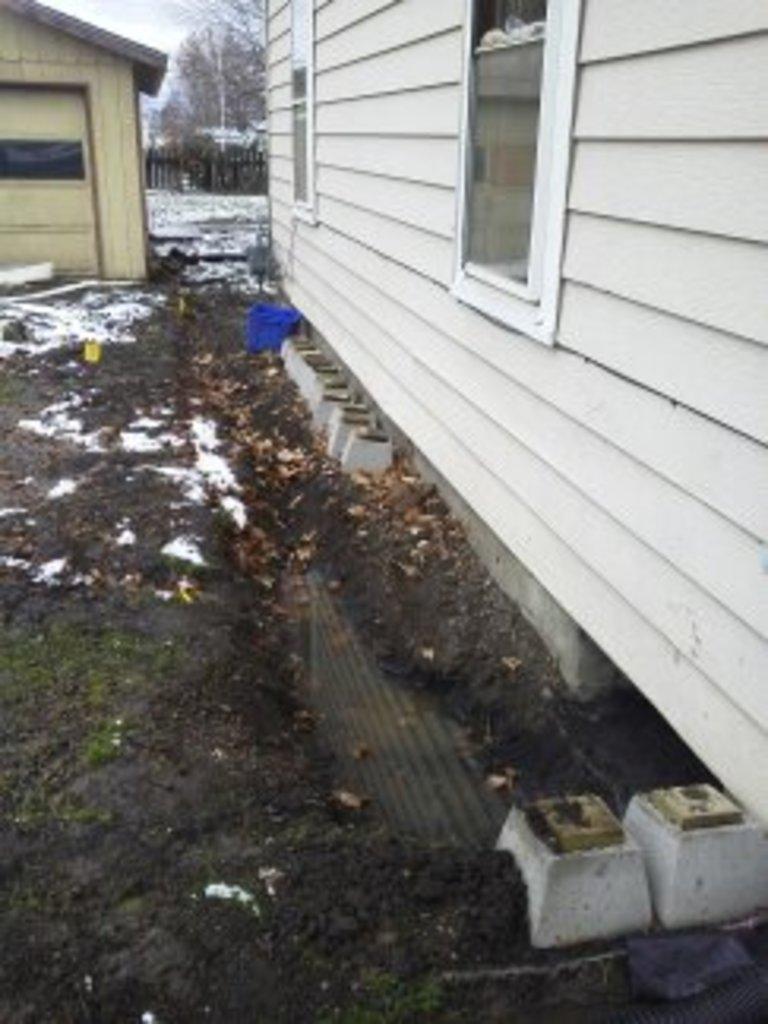In one or two sentences, can you explain what this image depicts? In this picture we can see houses, windows, mud and snow. In the background of the image we can see trees and fence. 